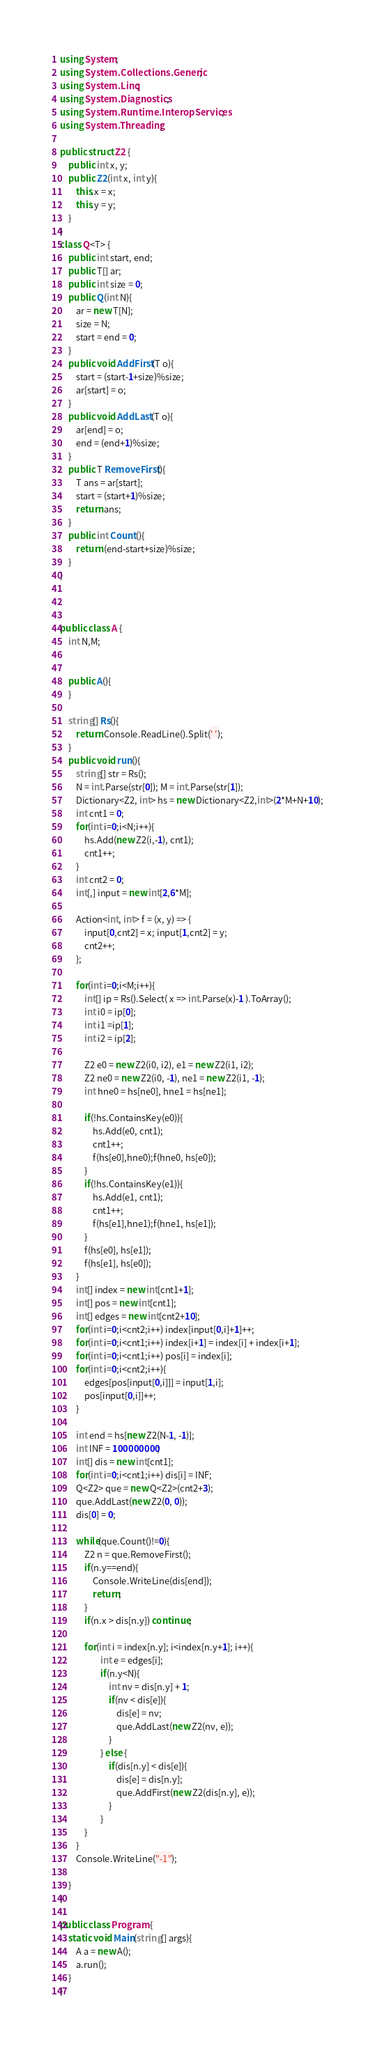Convert code to text. <code><loc_0><loc_0><loc_500><loc_500><_C#_>using System;
using System.Collections.Generic;
using System.Linq;
using System.Diagnostics;
using System.Runtime.InteropServices;
using System.Threading;

public struct Z2 {
    public int x, y;
    public Z2(int x, int y){
        this.x = x;
        this.y = y;
    }
}
class Q<T> {
	public int start, end;
	public T[] ar;
	public int size = 0;
	public Q(int N){
		ar = new T[N];
		size = N;
		start = end = 0;
	}
	public void AddFirst(T o){
		start = (start-1+size)%size;
		ar[start] = o;
	}
	public void AddLast(T o){
		ar[end] = o;
		end = (end+1)%size;
	}
	public T RemoveFirst(){
		T ans = ar[start];
		start = (start+1)%size;
		return ans;
	}
	public int Count(){
		return (end-start+size)%size;
	}
}

 
 
public class A {
	int N,M;
    
	
	public A(){
	}
	
	string[] Rs(){
		return Console.ReadLine().Split(' ');
	}
	public void run(){
        string[] str = Rs();
		N = int.Parse(str[0]); M = int.Parse(str[1]);
        Dictionary<Z2, int> hs = new Dictionary<Z2,int>(2*M+N+10);
        int cnt1 = 0;
        for(int i=0;i<N;i++){
            hs.Add(new Z2(i,-1), cnt1);
            cnt1++;
        }
        int cnt2 = 0;
        int[,] input = new int[2,6*M]; 
        
        Action<int, int> f = (x, y) => {
            input[0,cnt2] = x; input[1,cnt2] = y;
            cnt2++;
        };
        
        for(int i=0;i<M;i++){
            int[] ip = Rs().Select( x => int.Parse(x)-1 ).ToArray();
            int i0 = ip[0];
            int i1 =ip[1];
            int i2 = ip[2];
            
            Z2 e0 = new Z2(i0, i2), e1 = new Z2(i1, i2);
            Z2 ne0 = new Z2(i0, -1), ne1 = new Z2(i1, -1);
            int hne0 = hs[ne0], hne1 = hs[ne1];
            
            if(!hs.ContainsKey(e0)){
                hs.Add(e0, cnt1);
                cnt1++;
                f(hs[e0],hne0);f(hne0, hs[e0]);
            }
            if(!hs.ContainsKey(e1)){
                hs.Add(e1, cnt1);
                cnt1++;
                f(hs[e1],hne1);f(hne1, hs[e1]);
            }
            f(hs[e0], hs[e1]);
            f(hs[e1], hs[e0]);
        }
        int[] index = new int[cnt1+1];
        int[] pos = new int[cnt1];
        int[] edges = new int[cnt2+10];
        for(int i=0;i<cnt2;i++) index[input[0,i]+1]++;
        for(int i=0;i<cnt1;i++) index[i+1] = index[i] + index[i+1];
        for(int i=0;i<cnt1;i++) pos[i] = index[i];
        for(int i=0;i<cnt2;i++){
            edges[pos[input[0,i]]] = input[1,i];
            pos[input[0,i]]++;
        }
        
        int end = hs[new Z2(N-1, -1)];
        int INF = 100000000;
        int[] dis = new int[cnt1];
        for(int i=0;i<cnt1;i++) dis[i] = INF;
		Q<Z2> que = new Q<Z2>(cnt2+3);
		que.AddLast(new Z2(0, 0)); 
		dis[0] = 0;
       
		while(que.Count()!=0){
			Z2 n = que.RemoveFirst();
			if(n.y==end){ 
				Console.WriteLine(dis[end]);
				return;
			}
			if(n.x > dis[n.y]) continue;
			
            for(int i = index[n.y]; i<index[n.y+1]; i++){
                    int e = edges[i];
					if(n.y<N){
						int nv = dis[n.y] + 1;
	                    if(nv < dis[e]){
							dis[e] = nv;
							que.AddLast(new Z2(nv, e));
						}
					} else {
						if(dis[n.y] < dis[e]){
							dis[e] = dis[n.y];
							que.AddFirst(new Z2(dis[n.y], e));
						}
					}
            }
        }
		Console.WriteLine("-1");
        
	}
}
 
public class Program {
	static void Main(string[] args){
		A a = new A();
        a.run();
	}
}</code> 